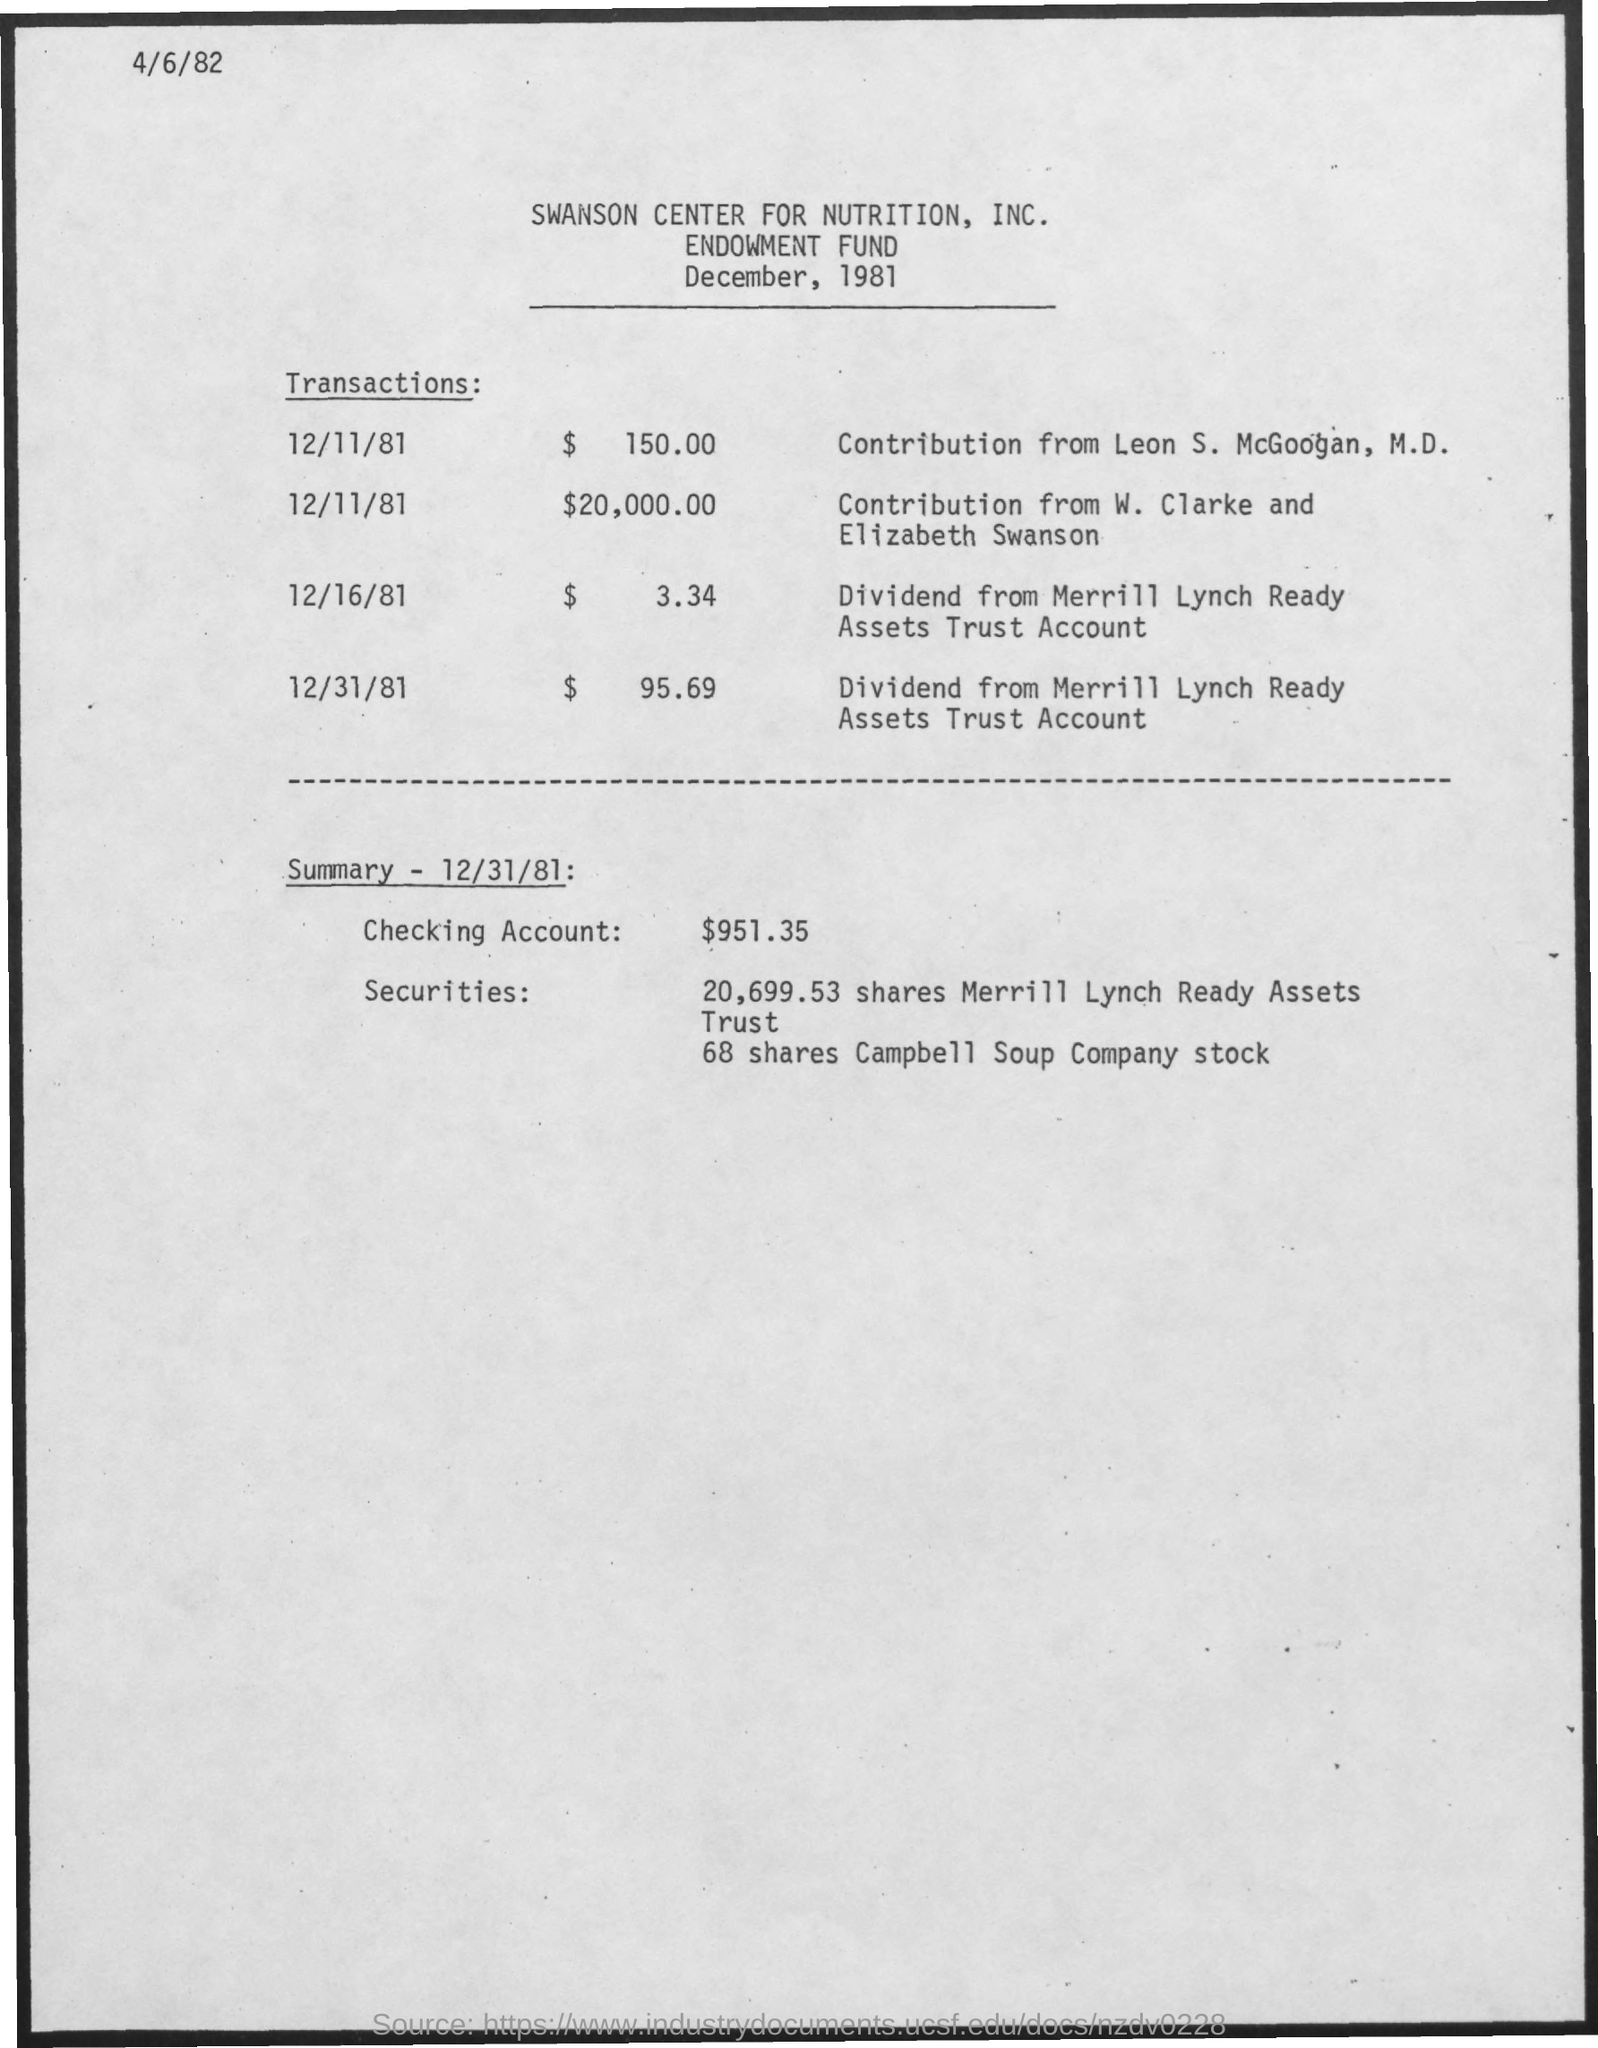Who contributed $ 150.00 on 12/11/81?
Your response must be concise. Leon S. McGoogan, M.D. How much is the contribution by W. Clarke and Elizabeth Swanson?
Provide a short and direct response. $20,000.00. What is the amount in Checking account?
Ensure brevity in your answer.  $951.35. 